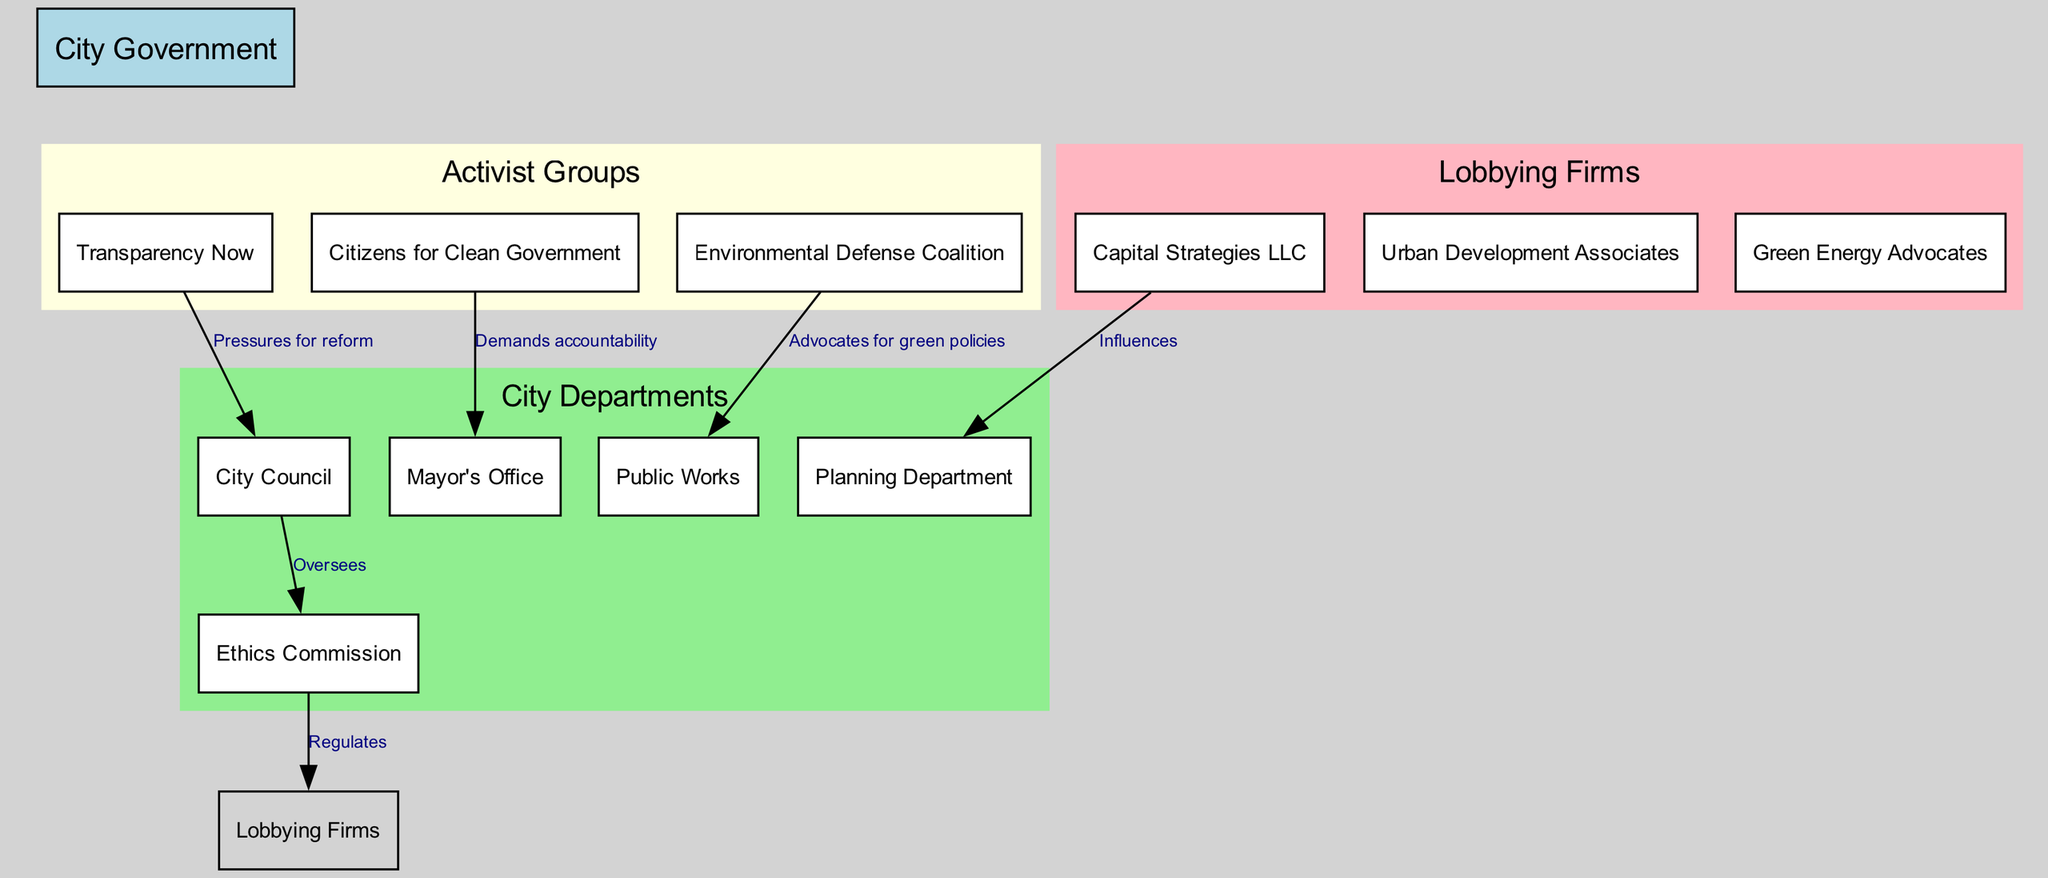What is the top-level node in the diagram? The top-level node is explicitly labeled as "City Government" in the diagram, which serves as the primary organizational entity from which all other nodes branch out.
Answer: City Government How many activist groups are present in the diagram? By counting the nodes specifically labeled under the "Activist Groups" section, there are three distinct groups represented in the diagram.
Answer: 3 Which department does the "Ethics Commission" oversee? The connection labeled "Oversees" from "City Council" to "Ethics Commission" indicates that the City Council is the entity responsible for overseeing the Ethics Commission.
Answer: City Council What type of relationship exists between "Capital Strategies LLC" and the "Planning Department"? The diagram indicates a direct influence from "Capital Strategies LLC" to the "Planning Department" through the labeled connection "Influences", indicating a one-way relationship.
Answer: Influences Which activist group demands accountability from the Mayor's Office? The node "Citizens for Clean Government" connects to the "Mayor's Office" with the label "Demands accountability", clarifying this group's specific focus in the diagram.
Answer: Citizens for Clean Government What is the role of the "Ethics Commission" regarding lobbying firms? The diagram shows that the "Ethics Commission" regulates lobbying firms, as indicated by the labeled connection between these two entities.
Answer: Regulates Which activist group advocates for green policies? In the diagram, "Environmental Defense Coalition" is directly connected to "Public Works" with the label "Advocates for green policies", identifying its specific role.
Answer: Environmental Defense Coalition What is the relationship label between "Transparency Now" and "City Council"? The labeled connection shows the relationship as "Pressures for reform", which illustrates the activist group's stance toward the City Council.
Answer: Pressures for reform How many connections originate from the "City Council"? By examining the outgoing edges from the "City Council" node, we find two connections: one to the "Ethics Commission" and another to "Transparency Now", resulting in a total of two connections.
Answer: 2 